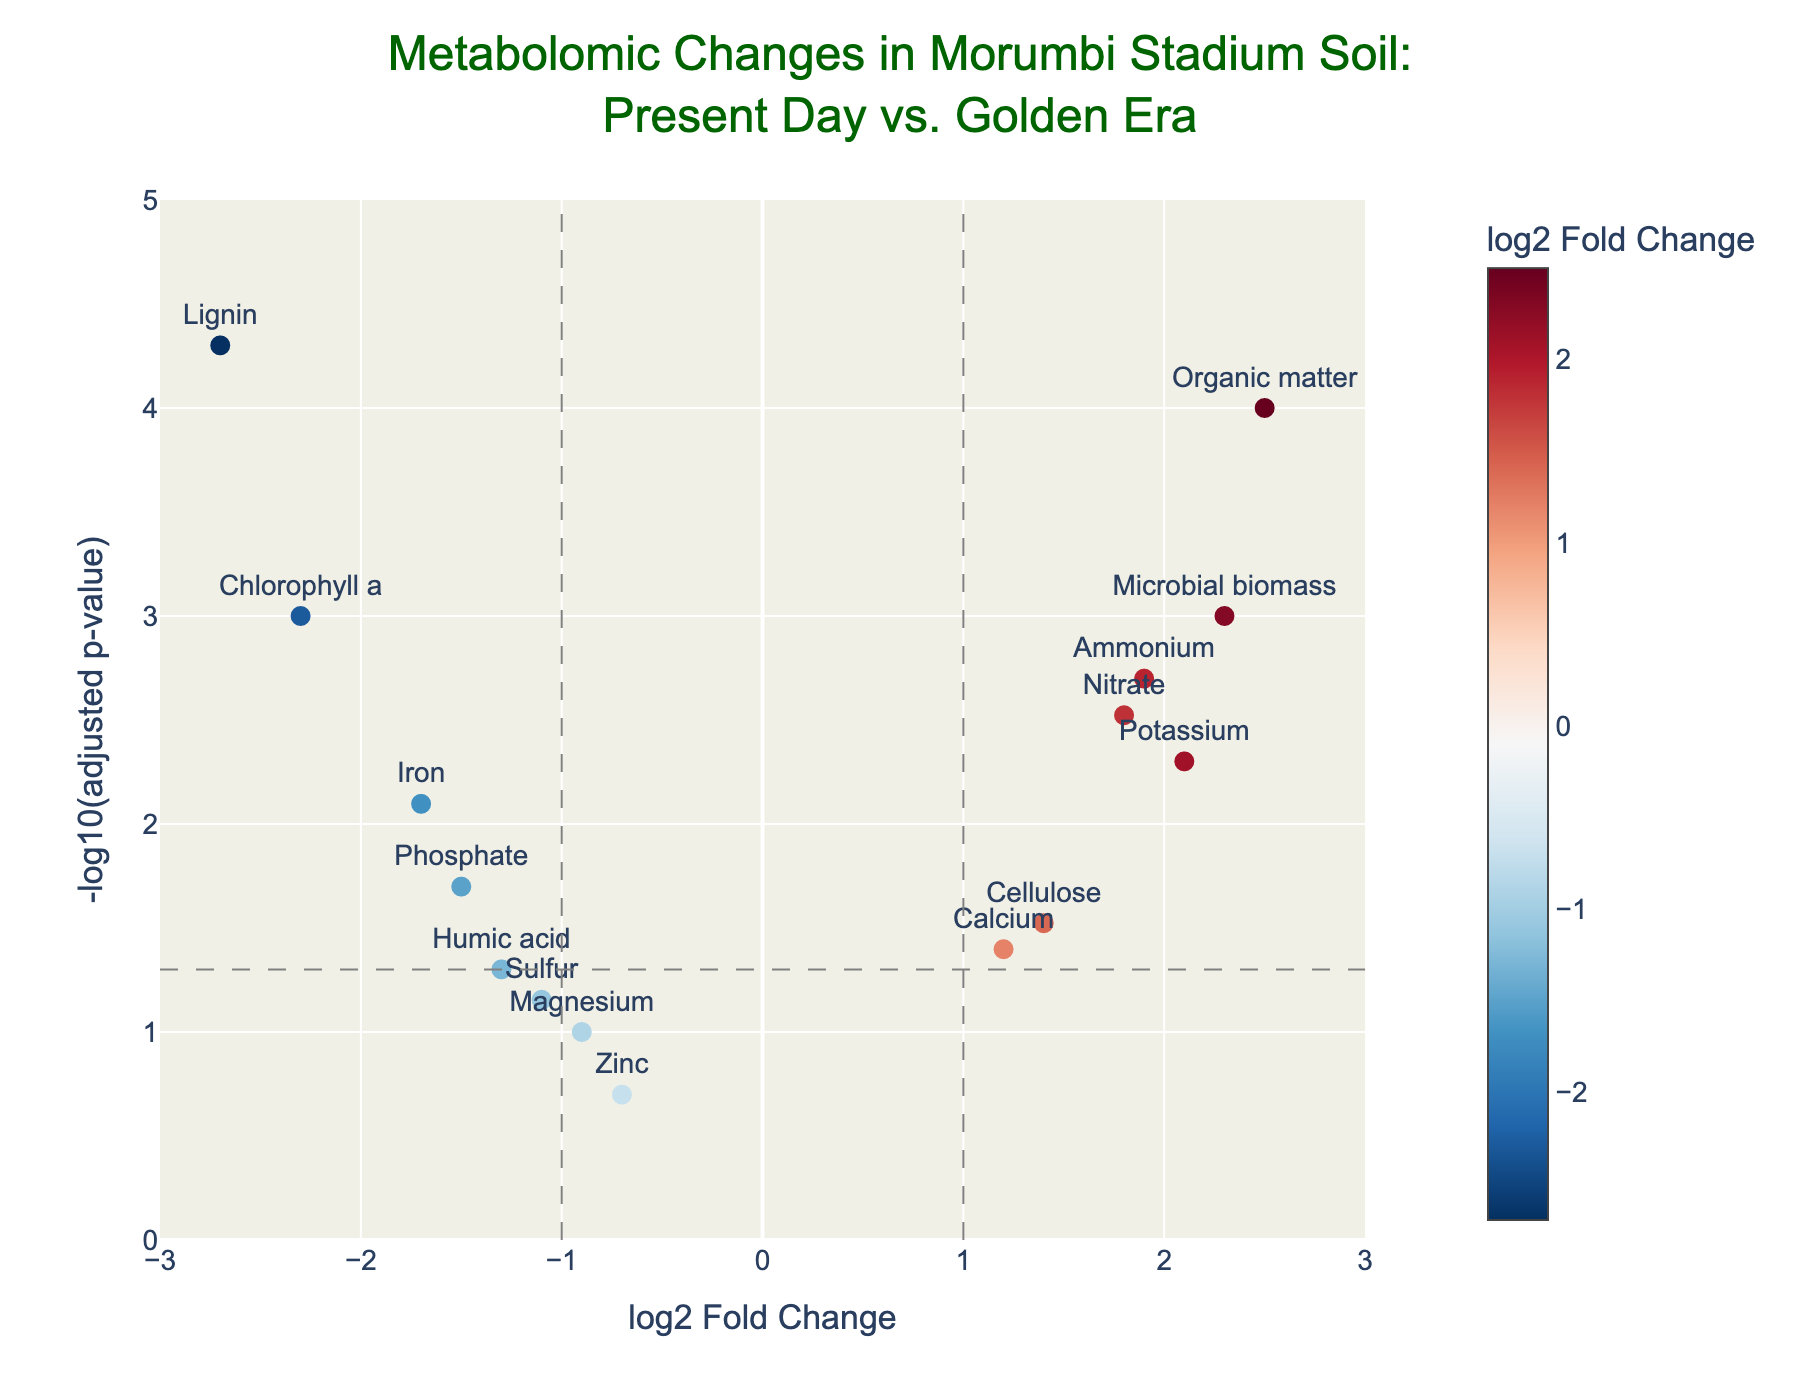What's the plot title? The title is centered at the top of the plot and can be read directly. It reads "Metabolomic Changes in Morumbi Stadium Soil: Present Day vs. Golden Era"
Answer: Metabolomic Changes in Morumbi Stadium Soil: Present Day vs. Golden Era What do the x-axis and y-axis represent? The x-axis and y-axis titles can be seen at their respective positions. The x-axis is labeled "log2 Fold Change" and the y-axis is labeled "-log10(adjusted p-value)".
Answer: x-axis: log2 Fold Change; y-axis: -log10(adjusted p-value) Which metabolite shows the highest positive log2 fold change and is significantly different? Identify the highest positive value on the x-axis, then verify if its y-value (significance) is above the threshold. The highest positive log2 fold change is 2.5, corresponding to Organic matter and is above the significance threshold.
Answer: Organic matter Identify a metabolite with a negative log2 fold change that has a high significance level (low p-adj). Look for metabolites on the left side of the plot (negative log2 fold change) with high y-values. Lignin has a log2 fold change of -2.7 and a high significance level (low p-adj).
Answer: Lignin How many metabolites are more significantly different today compared to the golden era? Count the metabolites above the significance threshold (horizontal line at y = -log10(0.05) = ~1.3). There are several points above this line, suggesting significant differences.
Answer: 10 metabolites Which metabolite has the lowest p-adj value and what is its log2 fold change? The lowest p-adj value corresponds to the highest y-value. Find this point and check its x-coordinate (log2 fold change). The metabolite is Lignin with a log2 fold change of -2.7.
Answer: Lignin, -2.7 Compare the log2 fold change values of Potassium and Calcium, and indicate which is higher. Locate Potassium and Calcium on the plot and compare their x-coordinates (log2 fold change values). Potassium is at 2.1, and Calcium is at 1.2.
Answer: Potassium What is the significance threshold, and how is it represented on the plot? The significance threshold is -log10(0.05), which equals ~1.3, represented by a horizontal dashed line across the plot.
Answer: ~1.3, horizontal dashed line Are there any metabolites with a log2 fold change between -1 and 1 that are also significant? Check the points between -1 and 1 on the x-axis and see if any are above the significance threshold (y > ~1.3). Magnesium (0.1) and Sulfur (0.07) are within the range but are not significant (y < 1.3). No metabolites fit both criteria.
Answer: No Which metabolite is located closest to the log2 fold change value of 0 but not significant? Identify points near the center of the x-axis (log2 fold change = 0) and check if they fall below the significance threshold. Zinc has a log2 fold change of -0.7 and is not significant.
Answer: Zinc 